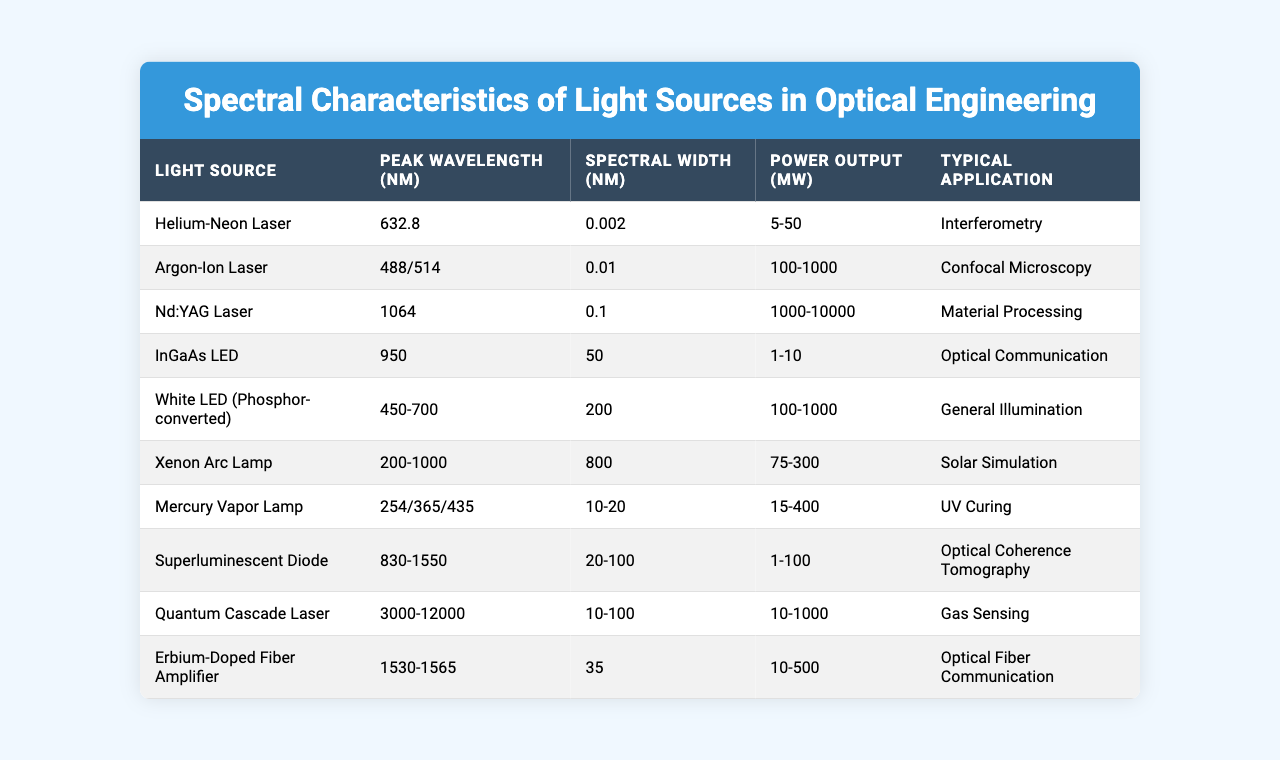What is the peak wavelength of the Helium-Neon Laser? The table lists the peak wavelength of the Helium-Neon Laser as 632.8 nm.
Answer: 632.8 nm Which light source has the highest power output range? By comparing the power output ranges in the table, the Nd:YAG Laser has the highest range of 1000-10000 mW.
Answer: Nd:YAG Laser Is the spectral width of the Xenon Arc Lamp greater than that of the Mercury Vapor Lamp? The spectral width of the Xenon Arc Lamp is 800 nm, while the Mercury Vapor Lamp has a width of 10-20 nm. Since 800 nm is greater than the maximum of 20 nm, the statement is true.
Answer: Yes What is the typical application of the Argon-Ion Laser? The table indicates that the typical application of the Argon-Ion Laser is for Confocal Microscopy.
Answer: Confocal Microscopy What is the difference in spectral width between the White LED and the Quantum Cascade Laser? The spectral width of the White LED is 200 nm and that of the Quantum Cascade Laser is 10-100 nm. The maximum spectral width difference is 200 nm - 100 nm = 100 nm.
Answer: 100 nm Which light source operates in the infrared region and typically used for optical communication? The InGaAs LED operates at a peak wavelength of 950 nm, which is in the infrared region and used for optical communication.
Answer: InGaAs LED What are the peak wavelengths offered by the Mercury Vapor Lamp? The table shows that the Mercury Vapor Lamp has peak wavelengths of 254, 365, and 435 nm.
Answer: 254, 365, 435 nm Among the listed light sources, which one has the smallest spectral width? The Helium-Neon Laser has the smallest spectral width at 0.002 nm.
Answer: Helium-Neon Laser What is the average power output of the Superluminescent Diode? The power output range for the Superluminescent Diode is 1-100 mW, so the average is calculated as (1 + 100)/2 = 50.5 mW.
Answer: 50.5 mW Does the Xenon Arc Lamp have a peak wavelength within the visible spectrum? The peak wavelength of the Xenon Arc Lamp is in the range of 200-1000 nm, which includes visible light (approximately 380-750 nm), thus the answer is true.
Answer: Yes 